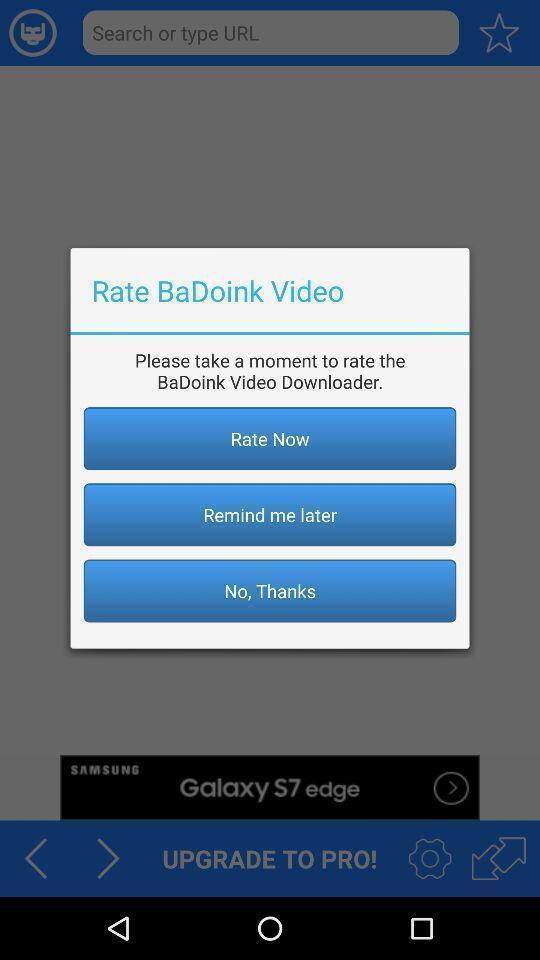Describe this image in words. Pop-up displaying to rate an app. 